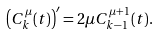Convert formula to latex. <formula><loc_0><loc_0><loc_500><loc_500>\left ( C _ { k } ^ { \mu } ( t ) \right ) ^ { \prime } = 2 \mu C _ { k - 1 } ^ { \mu + 1 } ( t ) .</formula> 